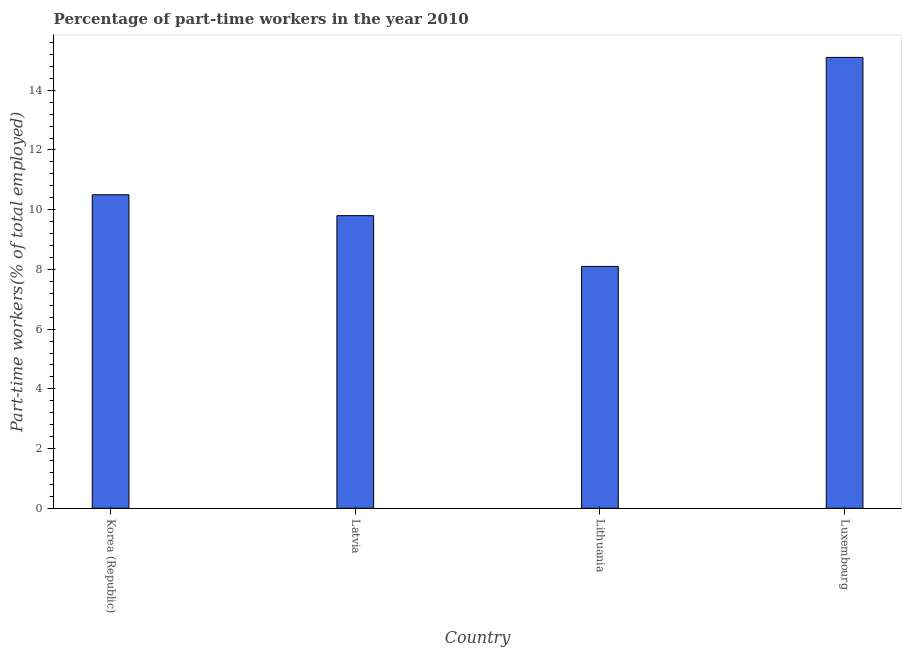Does the graph contain grids?
Offer a very short reply. No. What is the title of the graph?
Provide a short and direct response. Percentage of part-time workers in the year 2010. What is the label or title of the Y-axis?
Offer a very short reply. Part-time workers(% of total employed). Across all countries, what is the maximum percentage of part-time workers?
Your answer should be very brief. 15.1. Across all countries, what is the minimum percentage of part-time workers?
Your answer should be very brief. 8.1. In which country was the percentage of part-time workers maximum?
Offer a terse response. Luxembourg. In which country was the percentage of part-time workers minimum?
Your response must be concise. Lithuania. What is the sum of the percentage of part-time workers?
Provide a short and direct response. 43.5. What is the difference between the percentage of part-time workers in Latvia and Lithuania?
Your answer should be compact. 1.7. What is the average percentage of part-time workers per country?
Offer a terse response. 10.88. What is the median percentage of part-time workers?
Your response must be concise. 10.15. What is the ratio of the percentage of part-time workers in Lithuania to that in Luxembourg?
Provide a short and direct response. 0.54. Is the percentage of part-time workers in Lithuania less than that in Luxembourg?
Your answer should be compact. Yes. Is the difference between the percentage of part-time workers in Latvia and Luxembourg greater than the difference between any two countries?
Your response must be concise. No. What is the difference between the highest and the second highest percentage of part-time workers?
Offer a terse response. 4.6. What is the difference between the highest and the lowest percentage of part-time workers?
Keep it short and to the point. 7. Are all the bars in the graph horizontal?
Your answer should be very brief. No. What is the Part-time workers(% of total employed) in Latvia?
Give a very brief answer. 9.8. What is the Part-time workers(% of total employed) in Lithuania?
Ensure brevity in your answer.  8.1. What is the Part-time workers(% of total employed) of Luxembourg?
Give a very brief answer. 15.1. What is the difference between the Part-time workers(% of total employed) in Korea (Republic) and Latvia?
Ensure brevity in your answer.  0.7. What is the difference between the Part-time workers(% of total employed) in Korea (Republic) and Lithuania?
Give a very brief answer. 2.4. What is the difference between the Part-time workers(% of total employed) in Lithuania and Luxembourg?
Ensure brevity in your answer.  -7. What is the ratio of the Part-time workers(% of total employed) in Korea (Republic) to that in Latvia?
Offer a very short reply. 1.07. What is the ratio of the Part-time workers(% of total employed) in Korea (Republic) to that in Lithuania?
Your response must be concise. 1.3. What is the ratio of the Part-time workers(% of total employed) in Korea (Republic) to that in Luxembourg?
Provide a succinct answer. 0.69. What is the ratio of the Part-time workers(% of total employed) in Latvia to that in Lithuania?
Offer a very short reply. 1.21. What is the ratio of the Part-time workers(% of total employed) in Latvia to that in Luxembourg?
Offer a very short reply. 0.65. What is the ratio of the Part-time workers(% of total employed) in Lithuania to that in Luxembourg?
Make the answer very short. 0.54. 